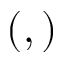<formula> <loc_0><loc_0><loc_500><loc_500>( , )</formula> 